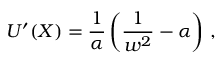<formula> <loc_0><loc_0><loc_500><loc_500>U ^ { \prime } ( X ) = \frac { 1 } { \alpha } \left ( \frac { 1 } w ^ { 2 } } - \alpha \right ) \, ,</formula> 